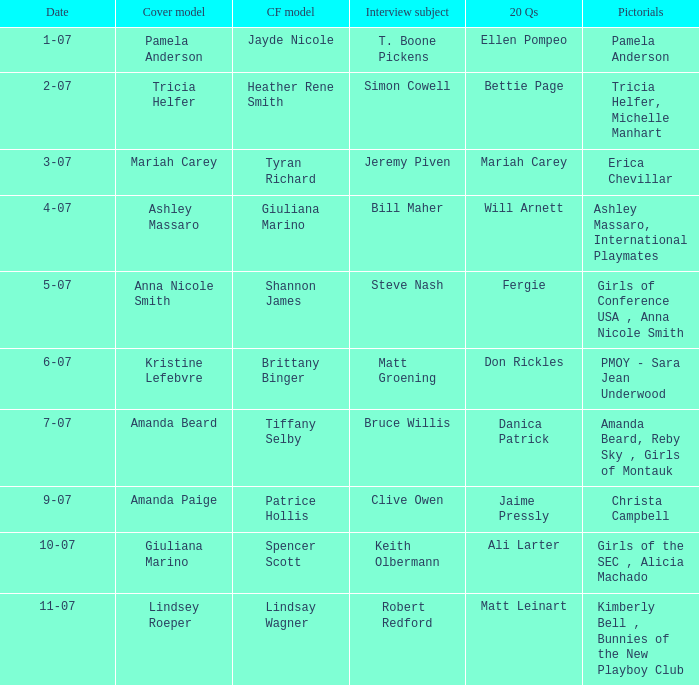Who was the centerfold model in the issue where Fergie answered the "20 questions"? Shannon James. 